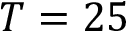<formula> <loc_0><loc_0><loc_500><loc_500>T = 2 5</formula> 